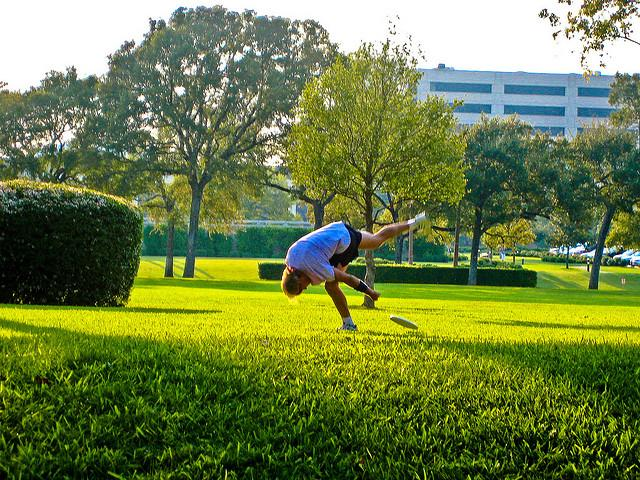What is the possible danger faced by the man?

Choices:
A) concussion
B) broken hip
C) broken backbone
D) broken wrist concussion 